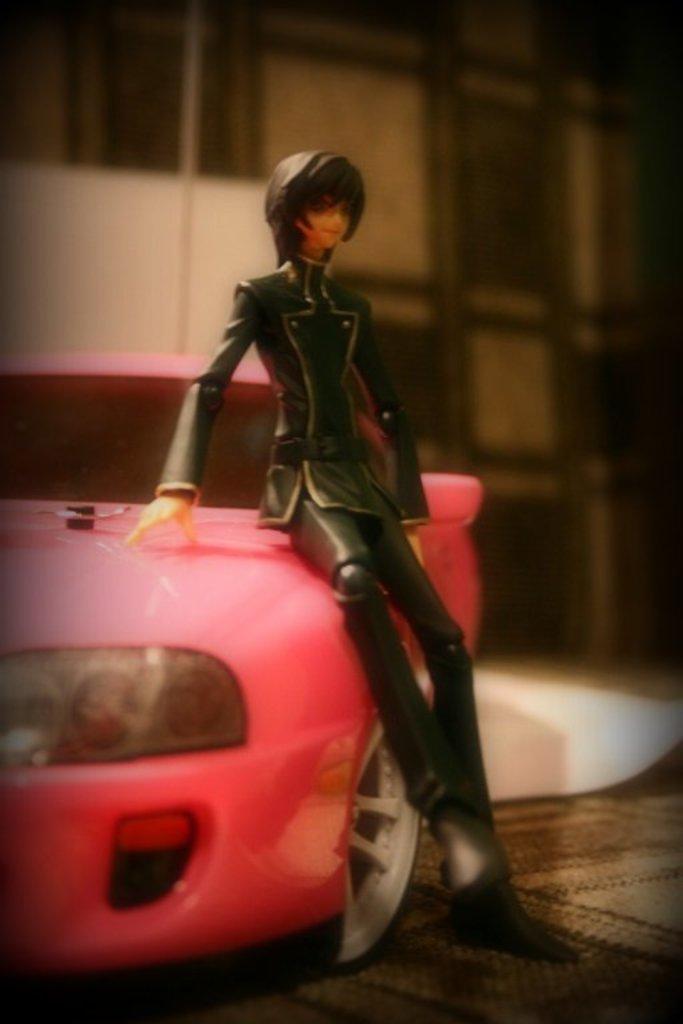Describe this image in one or two sentences. In this image I can see a pink color toy car and a doll. I can also see this doll is wearing black dress. I can see this image is little bit blurry from background. 